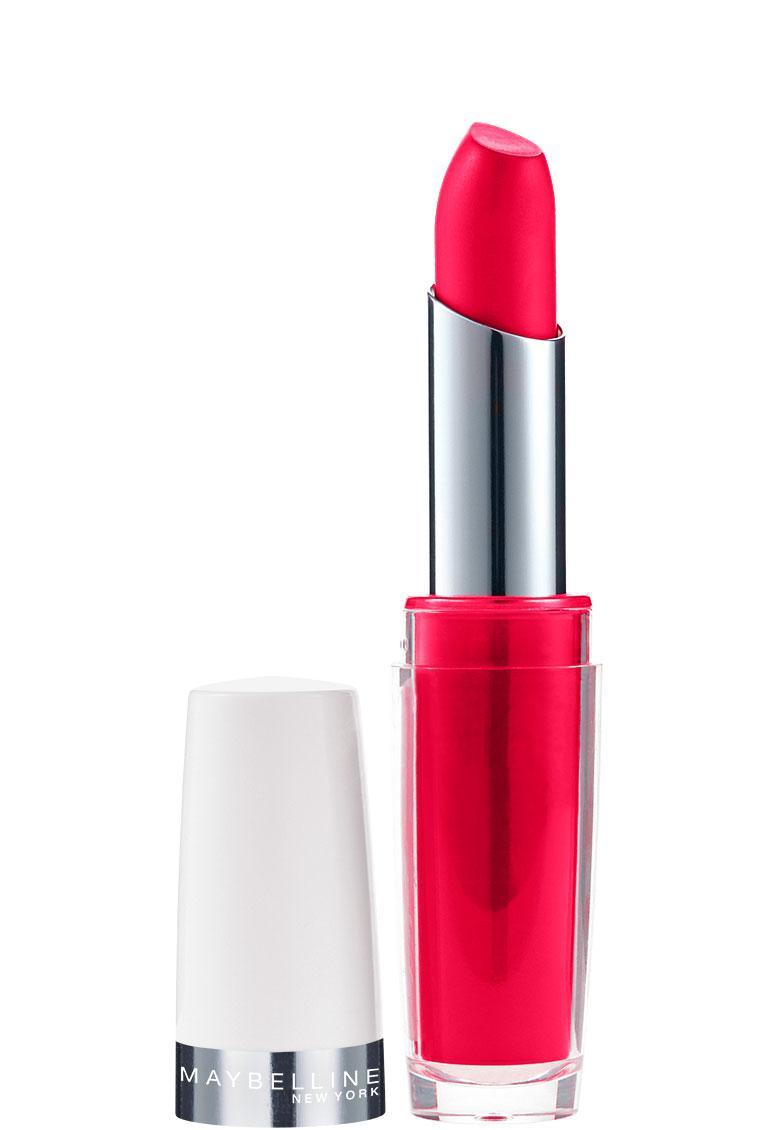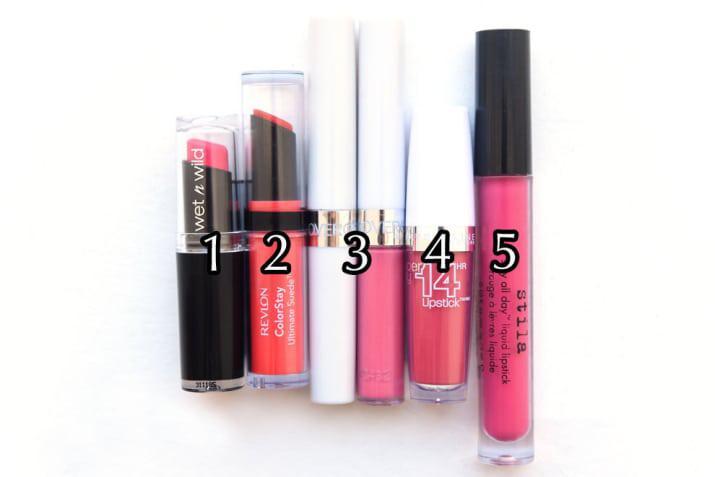The first image is the image on the left, the second image is the image on the right. Analyze the images presented: Is the assertion "The left image shows exactly one lipstick next to its cap." valid? Answer yes or no. Yes. The first image is the image on the left, the second image is the image on the right. Analyze the images presented: Is the assertion "The left image shows one lipstick next to its cap." valid? Answer yes or no. Yes. 